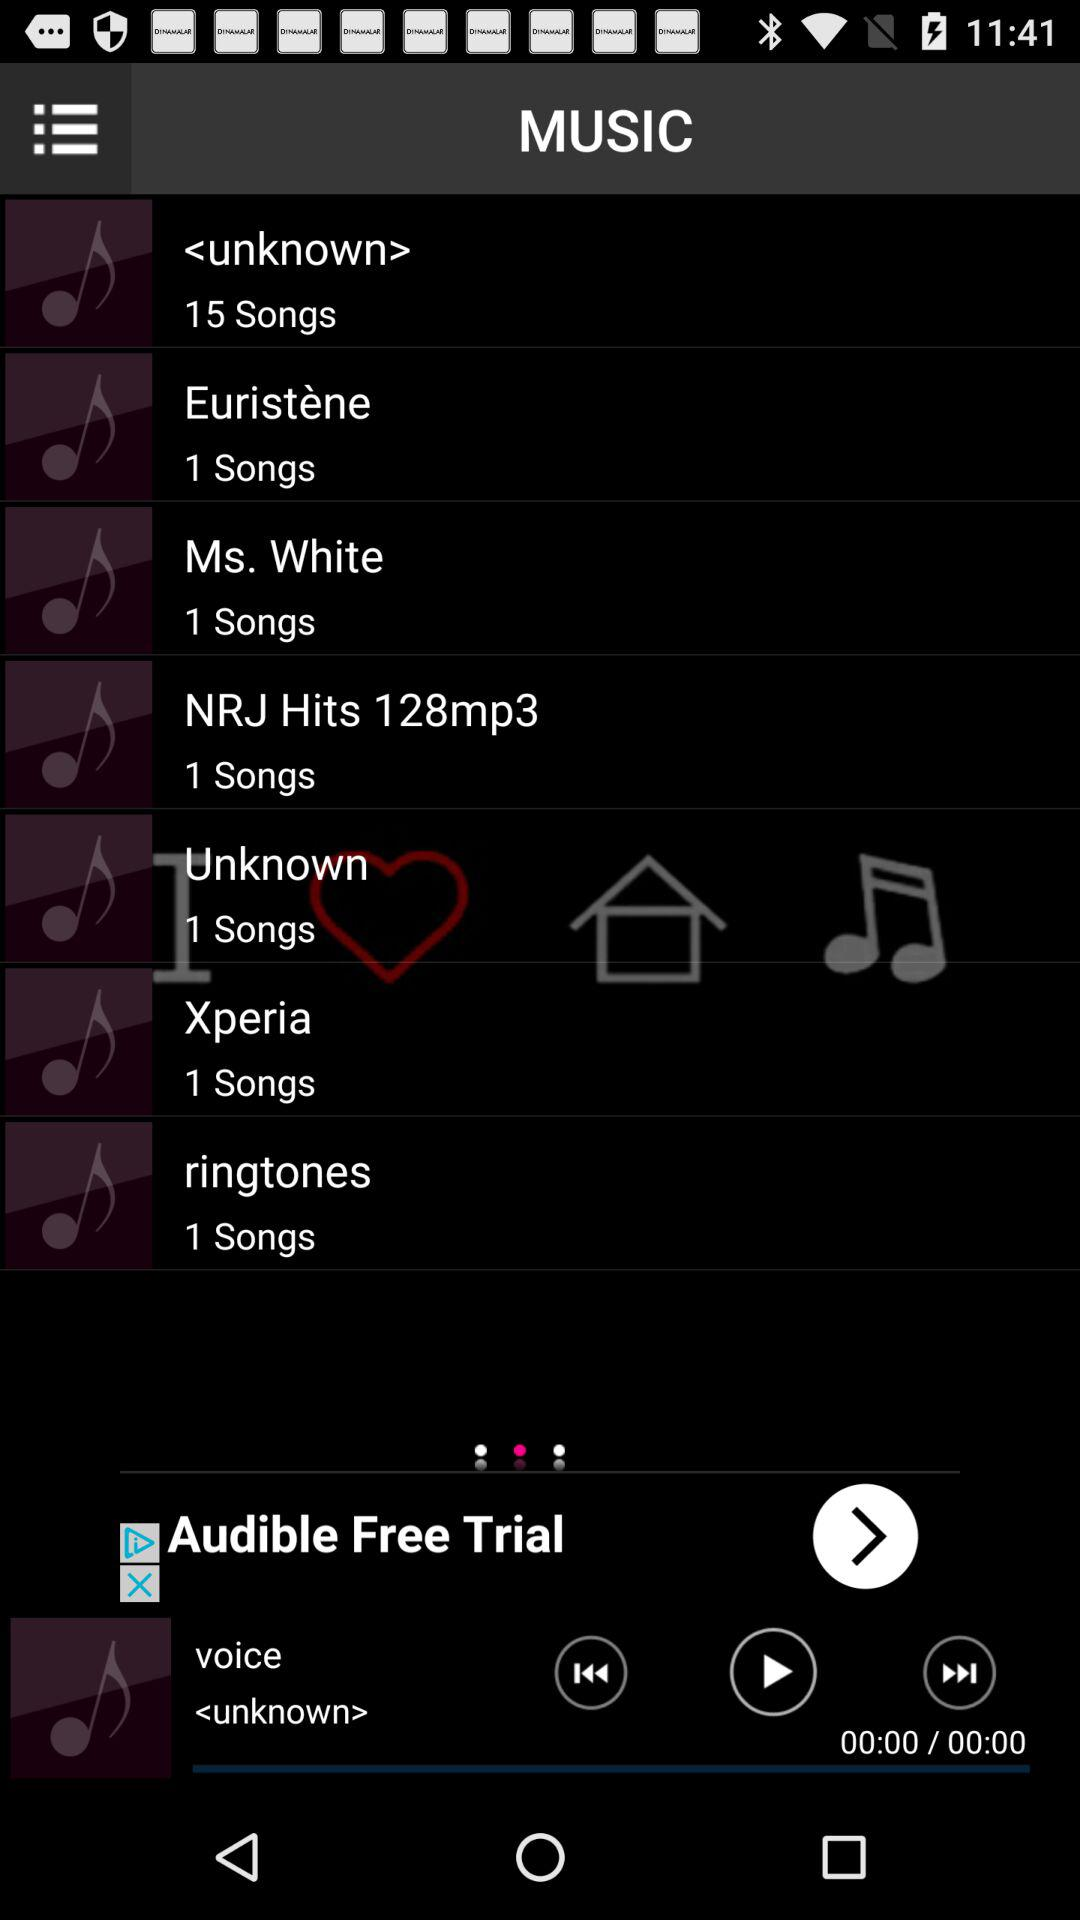How long is "Ms. White"?
When the provided information is insufficient, respond with <no answer>. <no answer> 